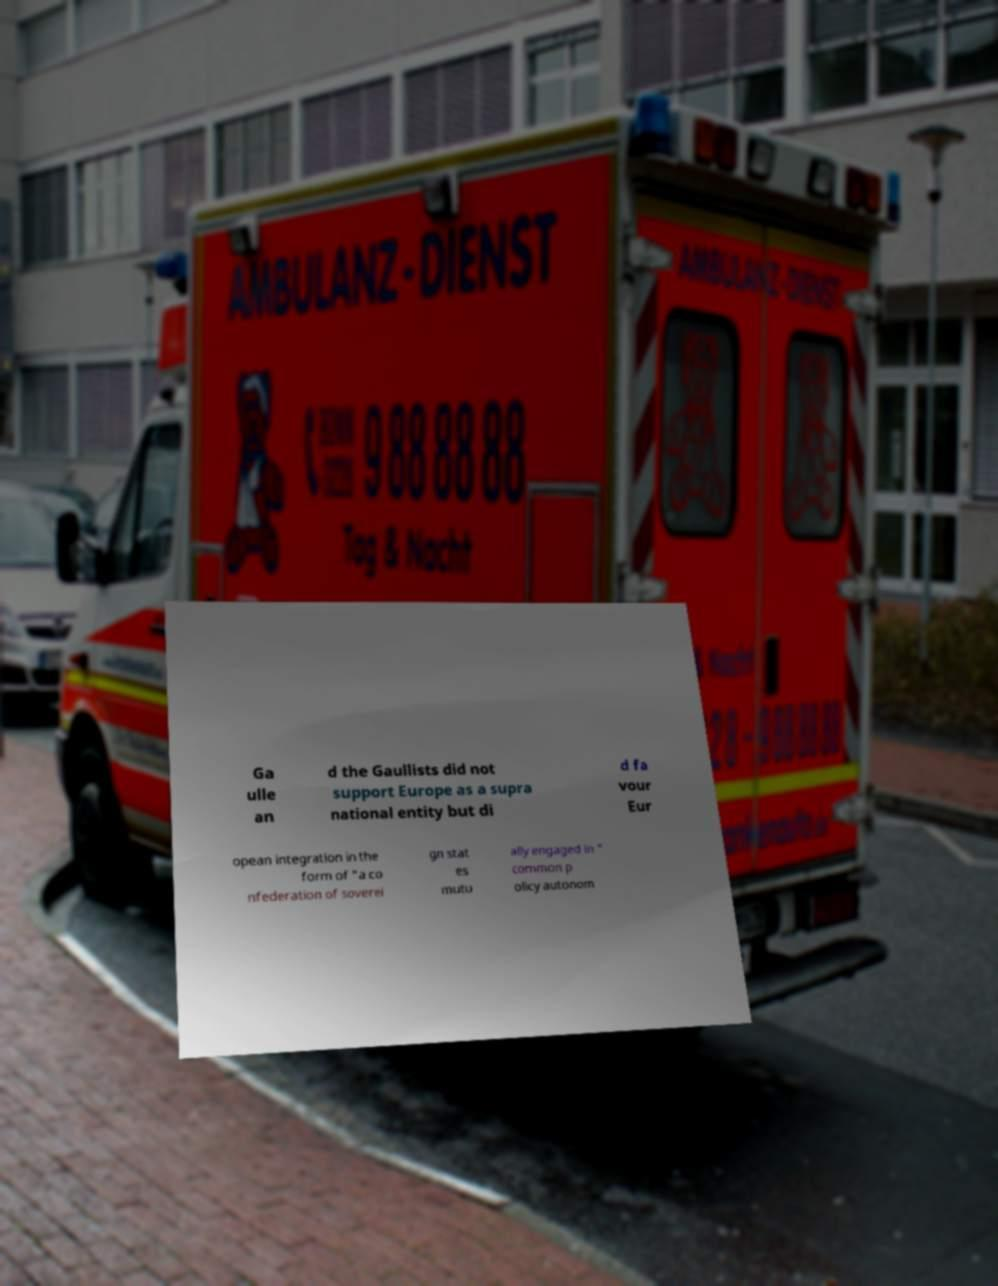Could you extract and type out the text from this image? Ga ulle an d the Gaullists did not support Europe as a supra national entity but di d fa vour Eur opean integration in the form of "a co nfederation of soverei gn stat es mutu ally engaged in " common p olicy autonom 